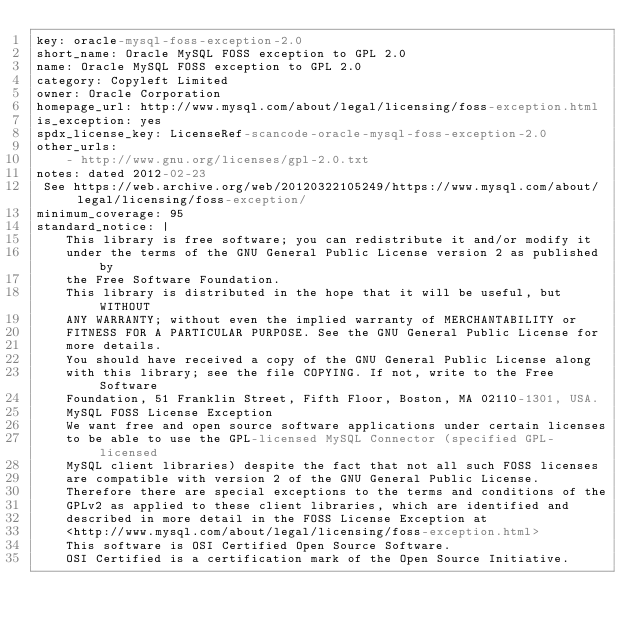Convert code to text. <code><loc_0><loc_0><loc_500><loc_500><_YAML_>key: oracle-mysql-foss-exception-2.0
short_name: Oracle MySQL FOSS exception to GPL 2.0
name: Oracle MySQL FOSS exception to GPL 2.0
category: Copyleft Limited
owner: Oracle Corporation
homepage_url: http://www.mysql.com/about/legal/licensing/foss-exception.html
is_exception: yes
spdx_license_key: LicenseRef-scancode-oracle-mysql-foss-exception-2.0
other_urls:
    - http://www.gnu.org/licenses/gpl-2.0.txt
notes: dated 2012-02-23
 See https://web.archive.org/web/20120322105249/https://www.mysql.com/about/legal/licensing/foss-exception/
minimum_coverage: 95
standard_notice: |
    This library is free software; you can redistribute it and/or modify it
    under the terms of the GNU General Public License version 2 as published by
    the Free Software Foundation.
    This library is distributed in the hope that it will be useful, but WITHOUT
    ANY WARRANTY; without even the implied warranty of MERCHANTABILITY or
    FITNESS FOR A PARTICULAR PURPOSE. See the GNU General Public License for
    more details.
    You should have received a copy of the GNU General Public License along
    with this library; see the file COPYING. If not, write to the Free Software
    Foundation, 51 Franklin Street, Fifth Floor, Boston, MA 02110-1301, USA.
    MySQL FOSS License Exception
    We want free and open source software applications under certain licenses
    to be able to use the GPL-licensed MySQL Connector (specified GPL-licensed
    MySQL client libraries) despite the fact that not all such FOSS licenses
    are compatible with version 2 of the GNU General Public License.
    Therefore there are special exceptions to the terms and conditions of the
    GPLv2 as applied to these client libraries, which are identified and
    described in more detail in the FOSS License Exception at
    <http://www.mysql.com/about/legal/licensing/foss-exception.html>
    This software is OSI Certified Open Source Software.
    OSI Certified is a certification mark of the Open Source Initiative.
</code> 